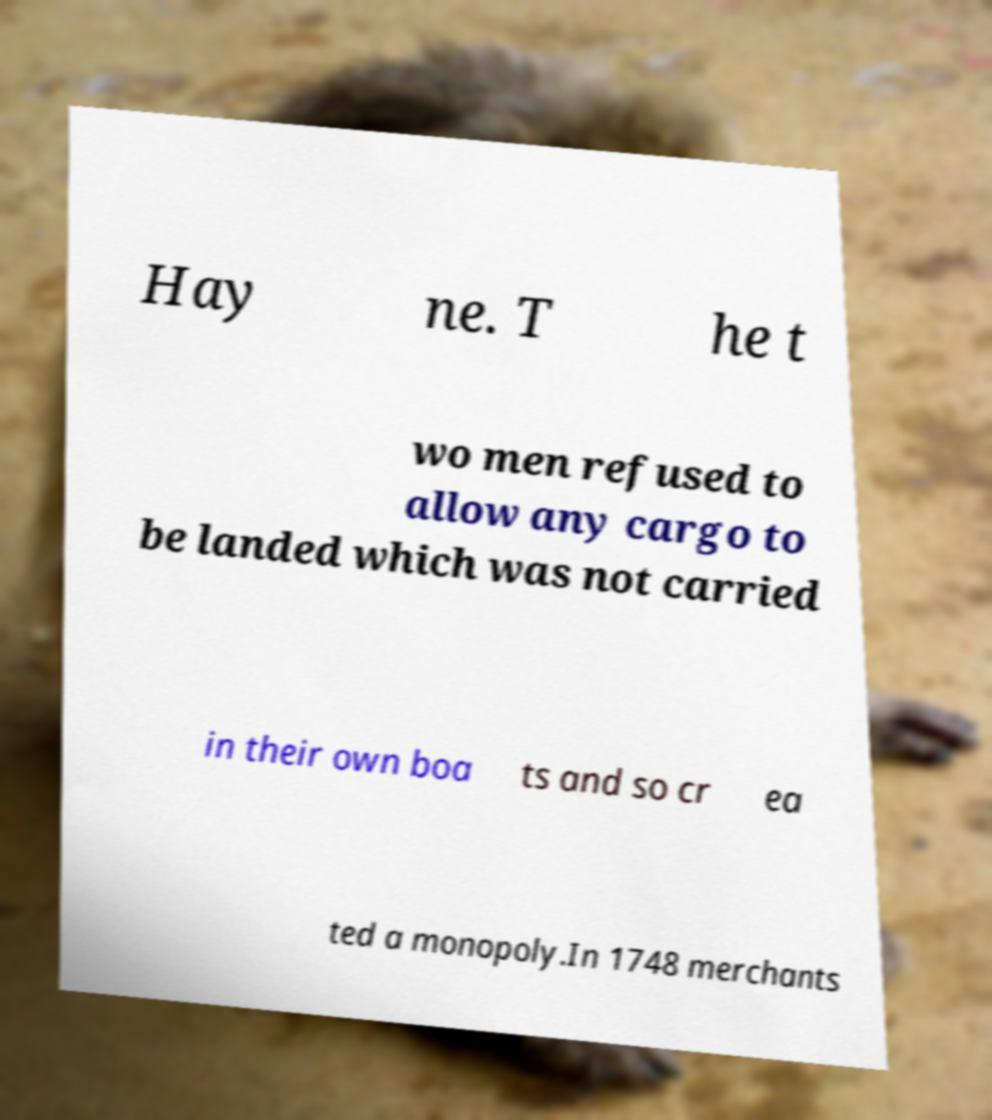Please read and relay the text visible in this image. What does it say? Hay ne. T he t wo men refused to allow any cargo to be landed which was not carried in their own boa ts and so cr ea ted a monopoly.In 1748 merchants 